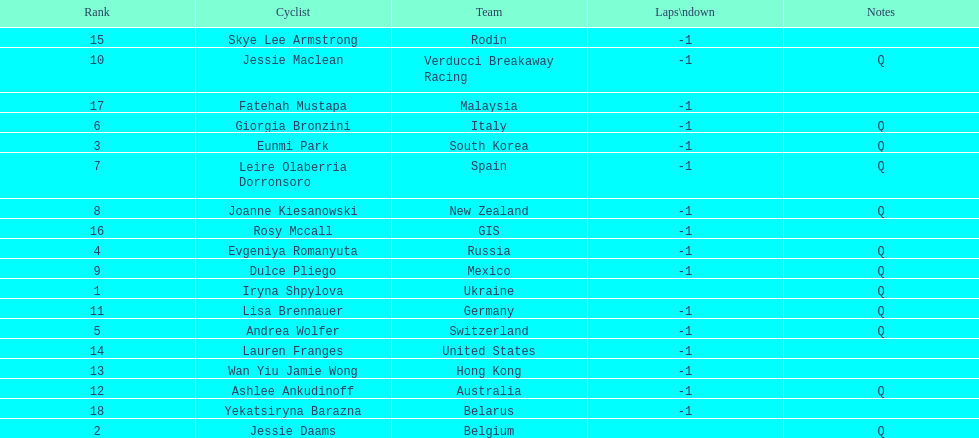What team is listed previous to belgium? Ukraine. 